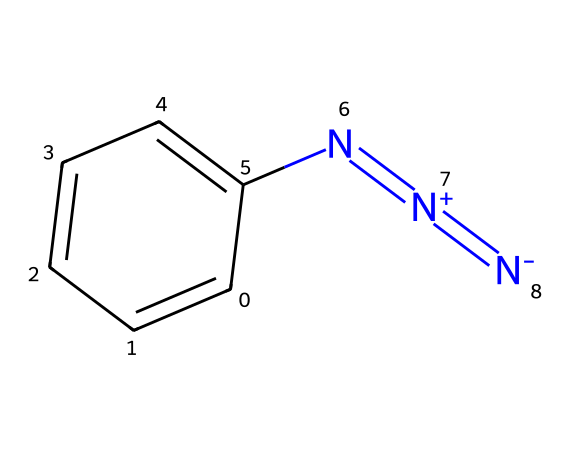What is the molecular formula of phenyl azide? The SMILES representation indicates that the compound contains a phenyl group (C6H5) attached to an azide group (N3). By combining these components, the molecular formula is determined to be C6H5N3.
Answer: C6H5N3 How many nitrogen atoms are in phenyl azide? Analyzing the SMILES notation shows one azide group represented by three nitrogen atoms (N=[N+]=[N-]). The phenyl group does not contribute any additional nitrogen. Therefore, the total number is three nitrogen atoms in phenyl azide.
Answer: 3 What type of functional group does the azide represent in this molecule? The azide functional group (N3) is represented in the SMILES as N=[N+]=[N-], indicating a linear arrangement of three nitrogen atoms. This correlates with the definition of an azide group in organic chemistry, which typically involves the −N3 structure.
Answer: azide Is phenyl azide stable under normal conditions? The electronic and structural features of phenyl azide indicate that it is generally considered unstable, particularly due to the presence of the azide functional group which is prone to decomposition or explosion under certain conditions.
Answer: unstable What type of reaction is phenyl azide commonly used in? Phenyl azide is frequently utilized in "click chemistry," which is a class of reactions that are highly efficient and selective, often involving the formation of triazoles through azide-alkyne cycloaddition.
Answer: click chemistry 